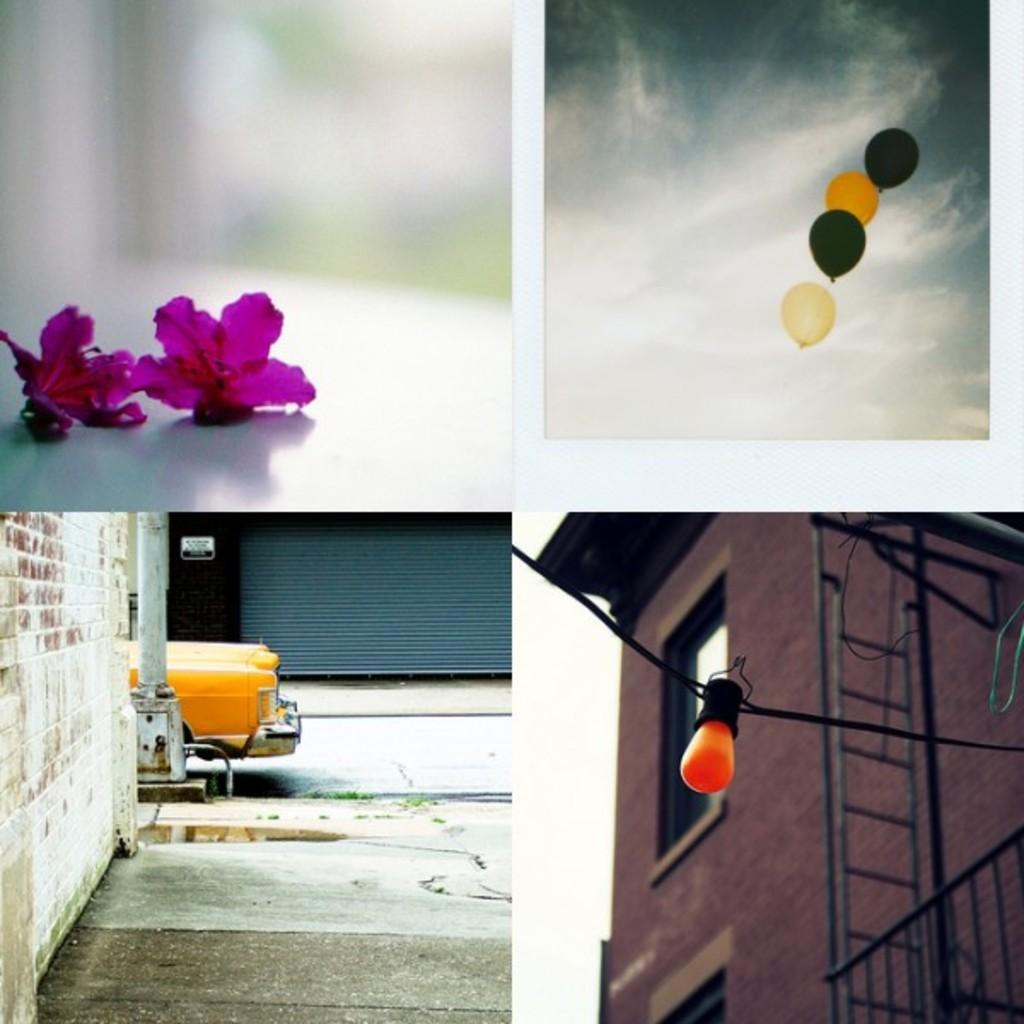How would you summarize this image in a sentence or two? This is a collage image, in this image there four pictures, in the first picture there are flowers, in the second picture there are balloons, in third picture there is a car on a road, in fourth picture there is a building and a light. 